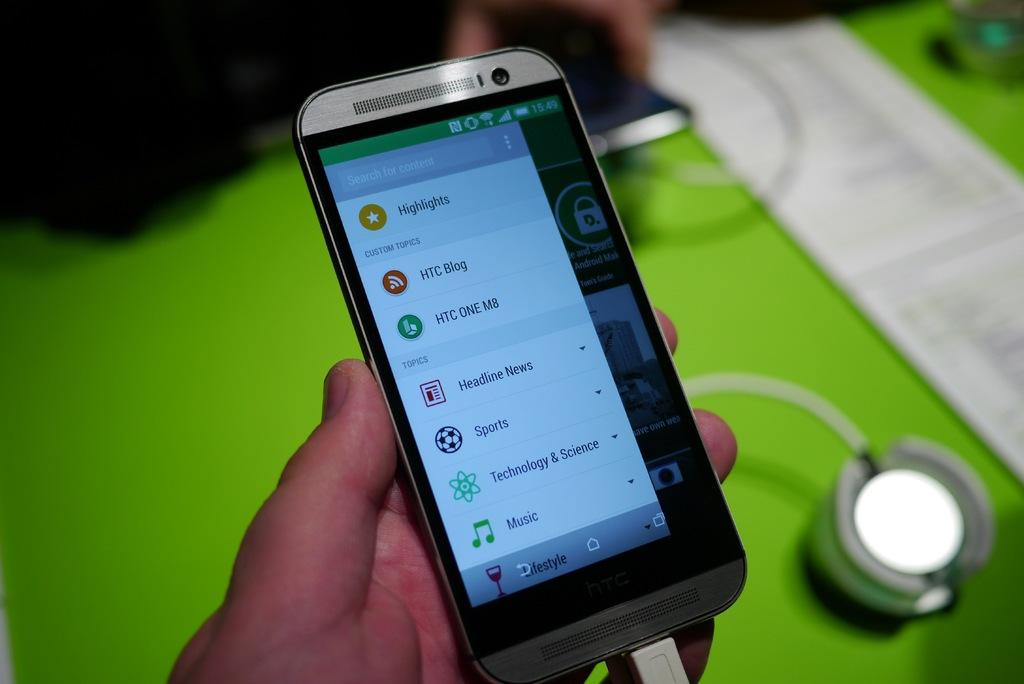<image>
Give a short and clear explanation of the subsequent image. A person holds a smartphone showing a list of menu items such as sports and music. 